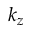<formula> <loc_0><loc_0><loc_500><loc_500>k _ { z }</formula> 